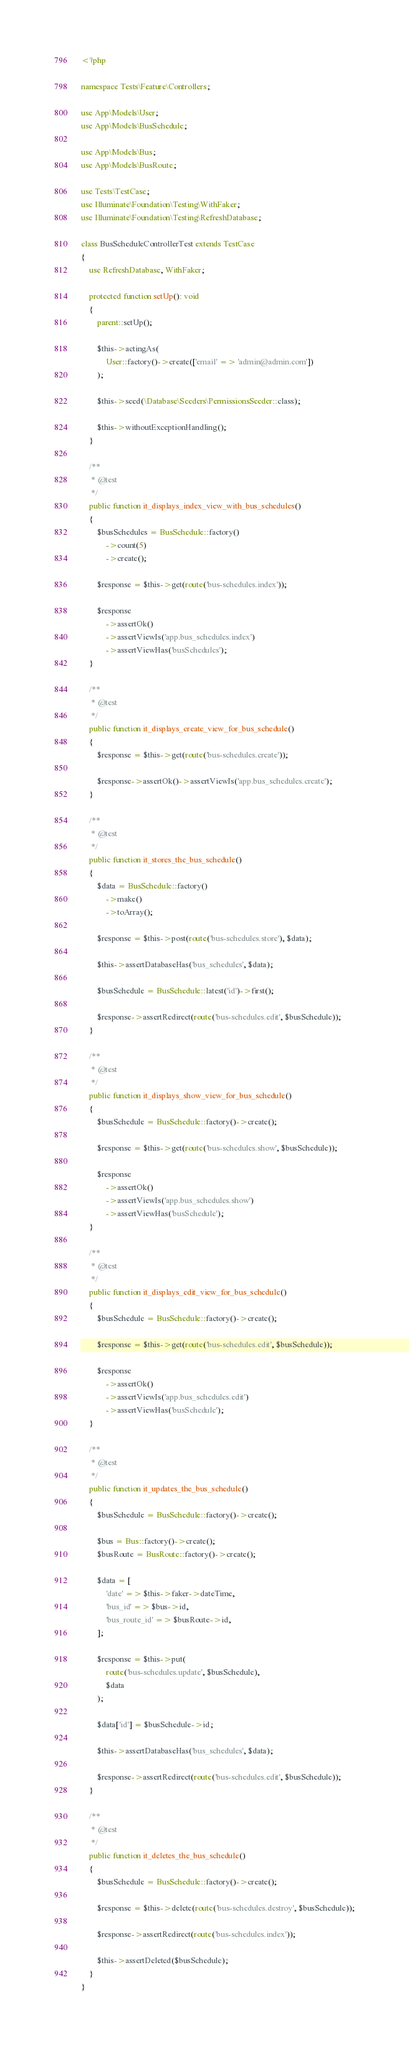<code> <loc_0><loc_0><loc_500><loc_500><_PHP_><?php

namespace Tests\Feature\Controllers;

use App\Models\User;
use App\Models\BusSchedule;

use App\Models\Bus;
use App\Models\BusRoute;

use Tests\TestCase;
use Illuminate\Foundation\Testing\WithFaker;
use Illuminate\Foundation\Testing\RefreshDatabase;

class BusScheduleControllerTest extends TestCase
{
    use RefreshDatabase, WithFaker;

    protected function setUp(): void
    {
        parent::setUp();

        $this->actingAs(
            User::factory()->create(['email' => 'admin@admin.com'])
        );

        $this->seed(\Database\Seeders\PermissionsSeeder::class);

        $this->withoutExceptionHandling();
    }

    /**
     * @test
     */
    public function it_displays_index_view_with_bus_schedules()
    {
        $busSchedules = BusSchedule::factory()
            ->count(5)
            ->create();

        $response = $this->get(route('bus-schedules.index'));

        $response
            ->assertOk()
            ->assertViewIs('app.bus_schedules.index')
            ->assertViewHas('busSchedules');
    }

    /**
     * @test
     */
    public function it_displays_create_view_for_bus_schedule()
    {
        $response = $this->get(route('bus-schedules.create'));

        $response->assertOk()->assertViewIs('app.bus_schedules.create');
    }

    /**
     * @test
     */
    public function it_stores_the_bus_schedule()
    {
        $data = BusSchedule::factory()
            ->make()
            ->toArray();

        $response = $this->post(route('bus-schedules.store'), $data);

        $this->assertDatabaseHas('bus_schedules', $data);

        $busSchedule = BusSchedule::latest('id')->first();

        $response->assertRedirect(route('bus-schedules.edit', $busSchedule));
    }

    /**
     * @test
     */
    public function it_displays_show_view_for_bus_schedule()
    {
        $busSchedule = BusSchedule::factory()->create();

        $response = $this->get(route('bus-schedules.show', $busSchedule));

        $response
            ->assertOk()
            ->assertViewIs('app.bus_schedules.show')
            ->assertViewHas('busSchedule');
    }

    /**
     * @test
     */
    public function it_displays_edit_view_for_bus_schedule()
    {
        $busSchedule = BusSchedule::factory()->create();

        $response = $this->get(route('bus-schedules.edit', $busSchedule));

        $response
            ->assertOk()
            ->assertViewIs('app.bus_schedules.edit')
            ->assertViewHas('busSchedule');
    }

    /**
     * @test
     */
    public function it_updates_the_bus_schedule()
    {
        $busSchedule = BusSchedule::factory()->create();

        $bus = Bus::factory()->create();
        $busRoute = BusRoute::factory()->create();

        $data = [
            'date' => $this->faker->dateTime,
            'bus_id' => $bus->id,
            'bus_route_id' => $busRoute->id,
        ];

        $response = $this->put(
            route('bus-schedules.update', $busSchedule),
            $data
        );

        $data['id'] = $busSchedule->id;

        $this->assertDatabaseHas('bus_schedules', $data);

        $response->assertRedirect(route('bus-schedules.edit', $busSchedule));
    }

    /**
     * @test
     */
    public function it_deletes_the_bus_schedule()
    {
        $busSchedule = BusSchedule::factory()->create();

        $response = $this->delete(route('bus-schedules.destroy', $busSchedule));

        $response->assertRedirect(route('bus-schedules.index'));

        $this->assertDeleted($busSchedule);
    }
}
</code> 